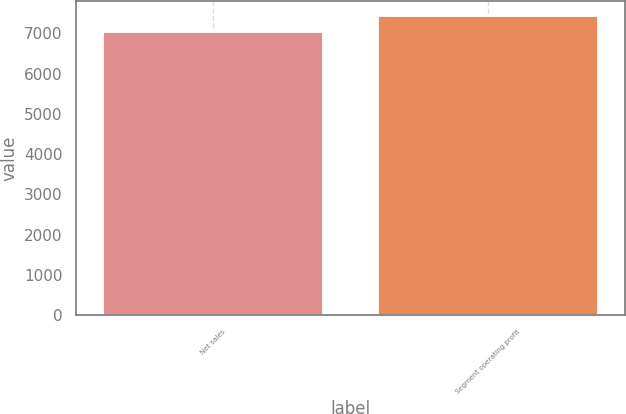Convert chart to OTSL. <chart><loc_0><loc_0><loc_500><loc_500><bar_chart><fcel>Net sales<fcel>Segment operating profit<nl><fcel>7028<fcel>7441<nl></chart> 